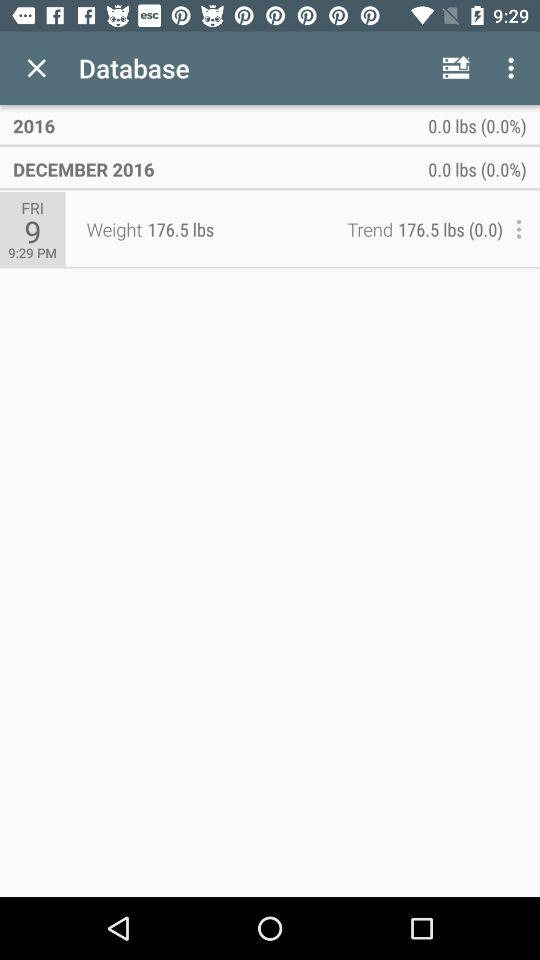What is the day on which weight is measured? The day is Friday, December 9, 2016. 